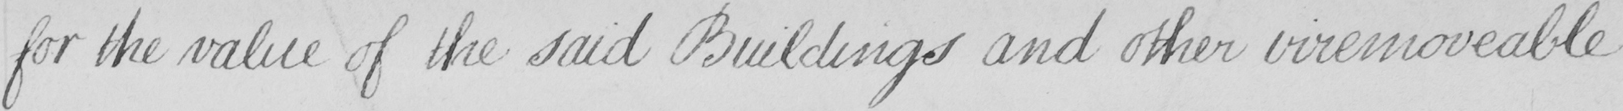Please transcribe the handwritten text in this image. for the value of the said Buildings and other irremoveable 